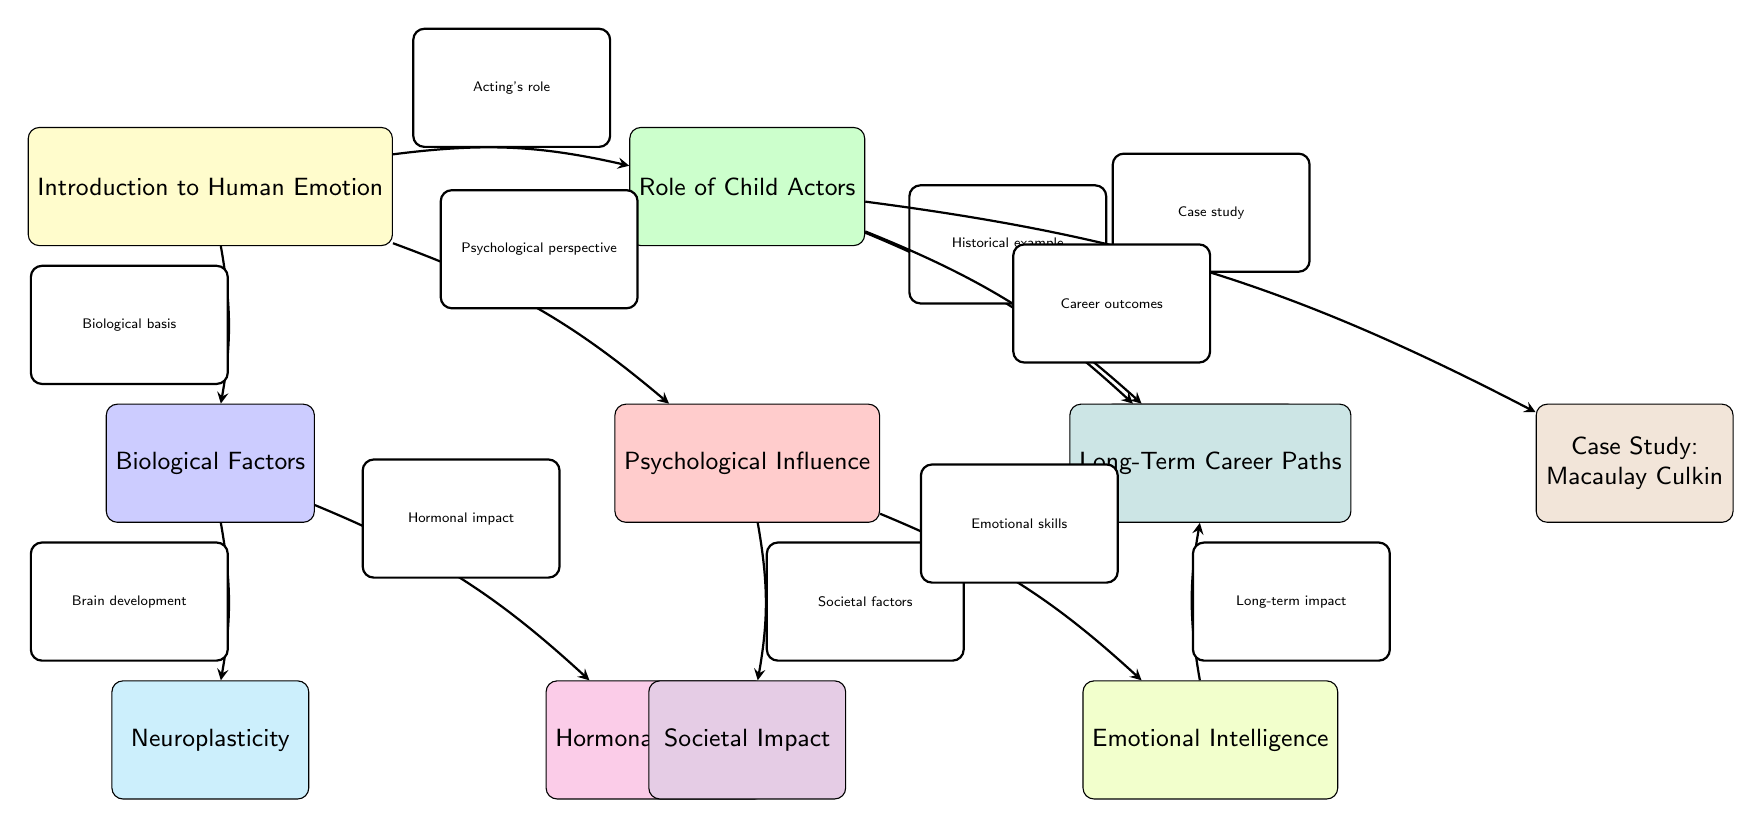What is the focus of the first node? The first node is labeled "Introduction to Human Emotion," indicating that this is the primary topic introduced in the diagram.
Answer: Introduction to Human Emotion How many case studies are presented in the diagram? There are two case studies identified in the diagram: one for Shirley Temple and one for Macaulay Culkin.
Answer: 2 Which node is connected directly to "Biological Factors"? The node "Neuroplasticity" is connected directly to "Biological Factors" through an edge labeled "Brain development."
Answer: Neuroplasticity What relationship exists between "Psychological Influence" and "Societal Impact"? The relationship is represented by the edge labeled "Societal factors" indicating that Psychological Influence has an effect on Societal Impact.
Answer: Societal factors What do "Emotional Intelligence" and "Long-Term Career Paths" have in common? Both nodes are linked by an edge labeled "Long-term impact," showing that Emotional Intelligence influences Long-Term Career Paths.
Answer: Long-term impact Which node serves as a primary example in the context of child actors? The node "Case Study: Shirley Temple" serves as a primary example, specifically addressing the role of child actors.
Answer: Case Study: Shirley Temple What two biological components are discussed in relation to "Biological Factors"? The components mentioned are "Neuroplasticity" and "Hormonal Changes," as both are directly connected to Biological Factors.
Answer: Neuroplasticity, Hormonal Changes Which node represents the outcome of career paths for child actors? The node titled "Long-Term Career Paths" indicates the resulting paths that child actors take as a consequence of their experiences.
Answer: Long-Term Career Paths What is the direction of influence from "Child Actors" to "Career Outcomes"? The influence flows from "Role of Child Actors" to "Career Outcomes," shown by the edge labeled "Career outcomes."
Answer: Career outcomes 